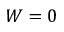<formula> <loc_0><loc_0><loc_500><loc_500>W = 0</formula> 